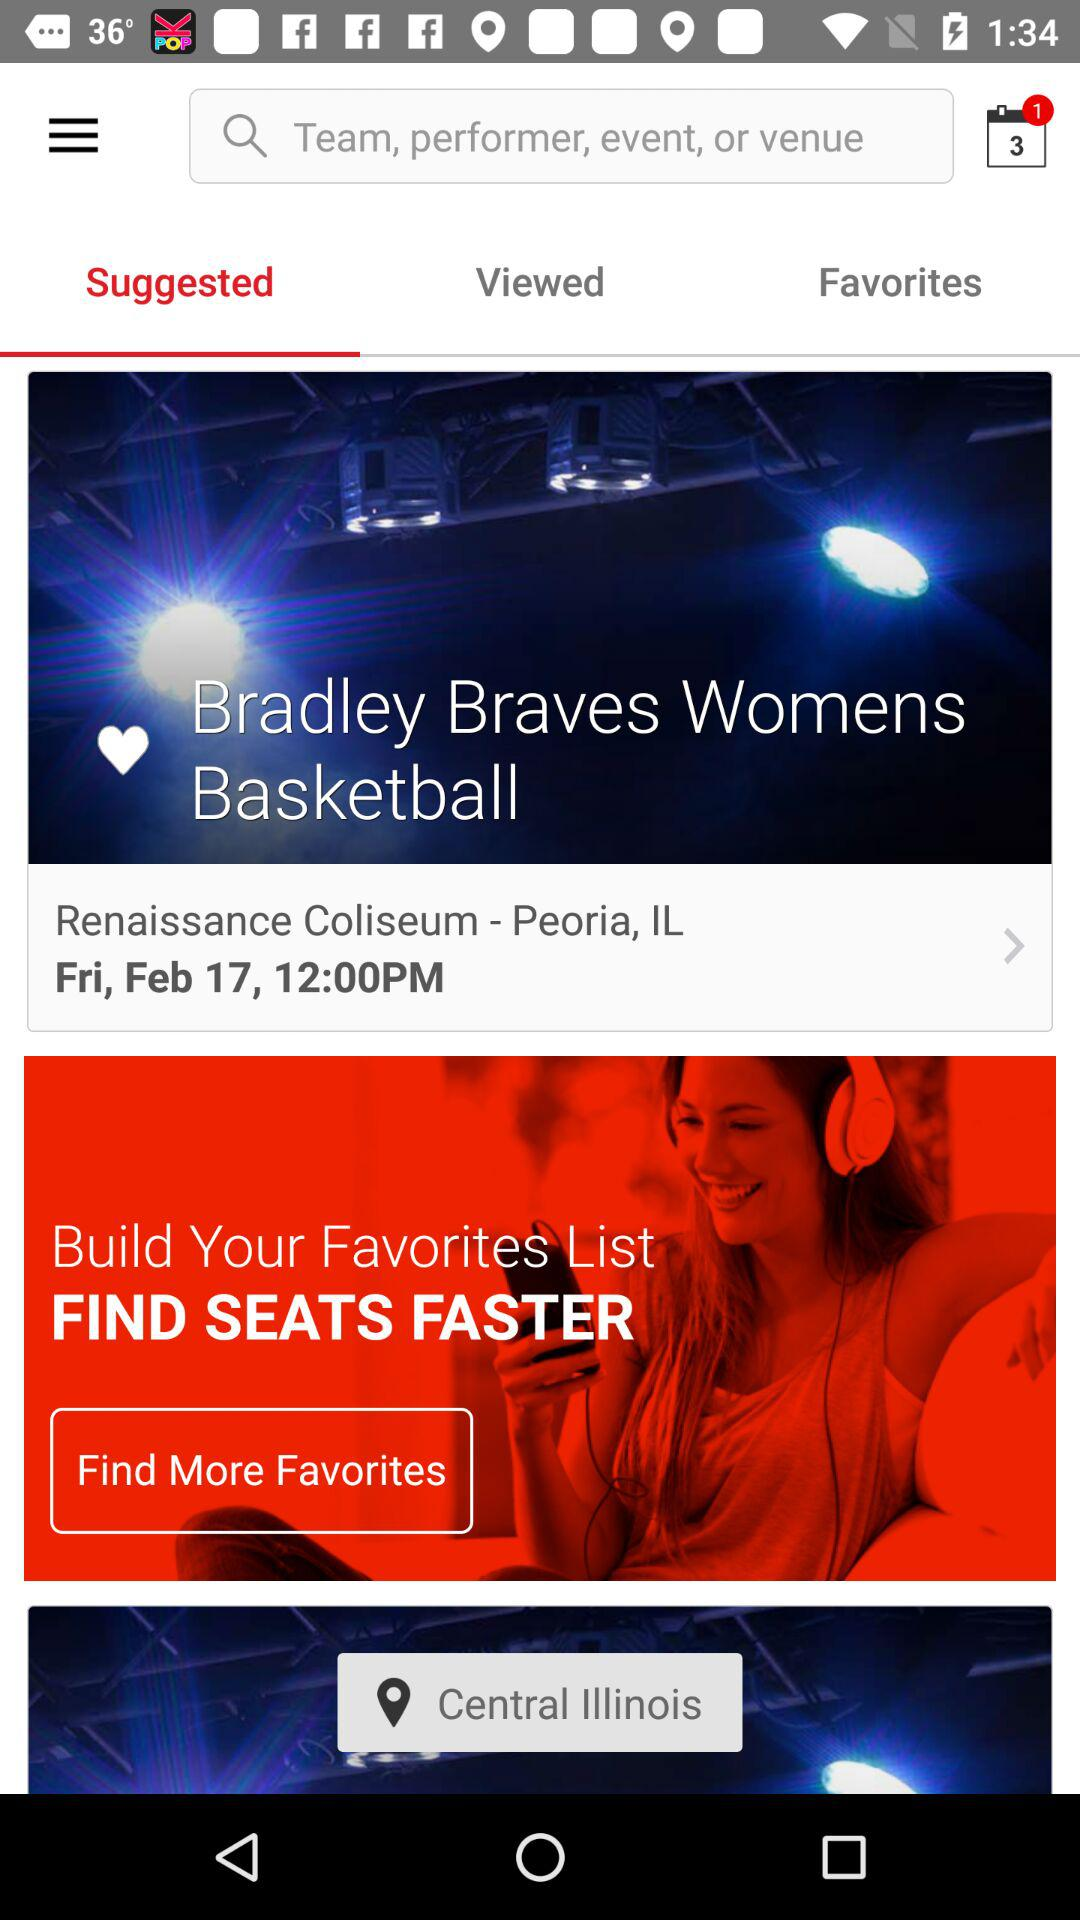What's the basketball team name? The basketball team name is "Bradley Braves Womens Basketball". 